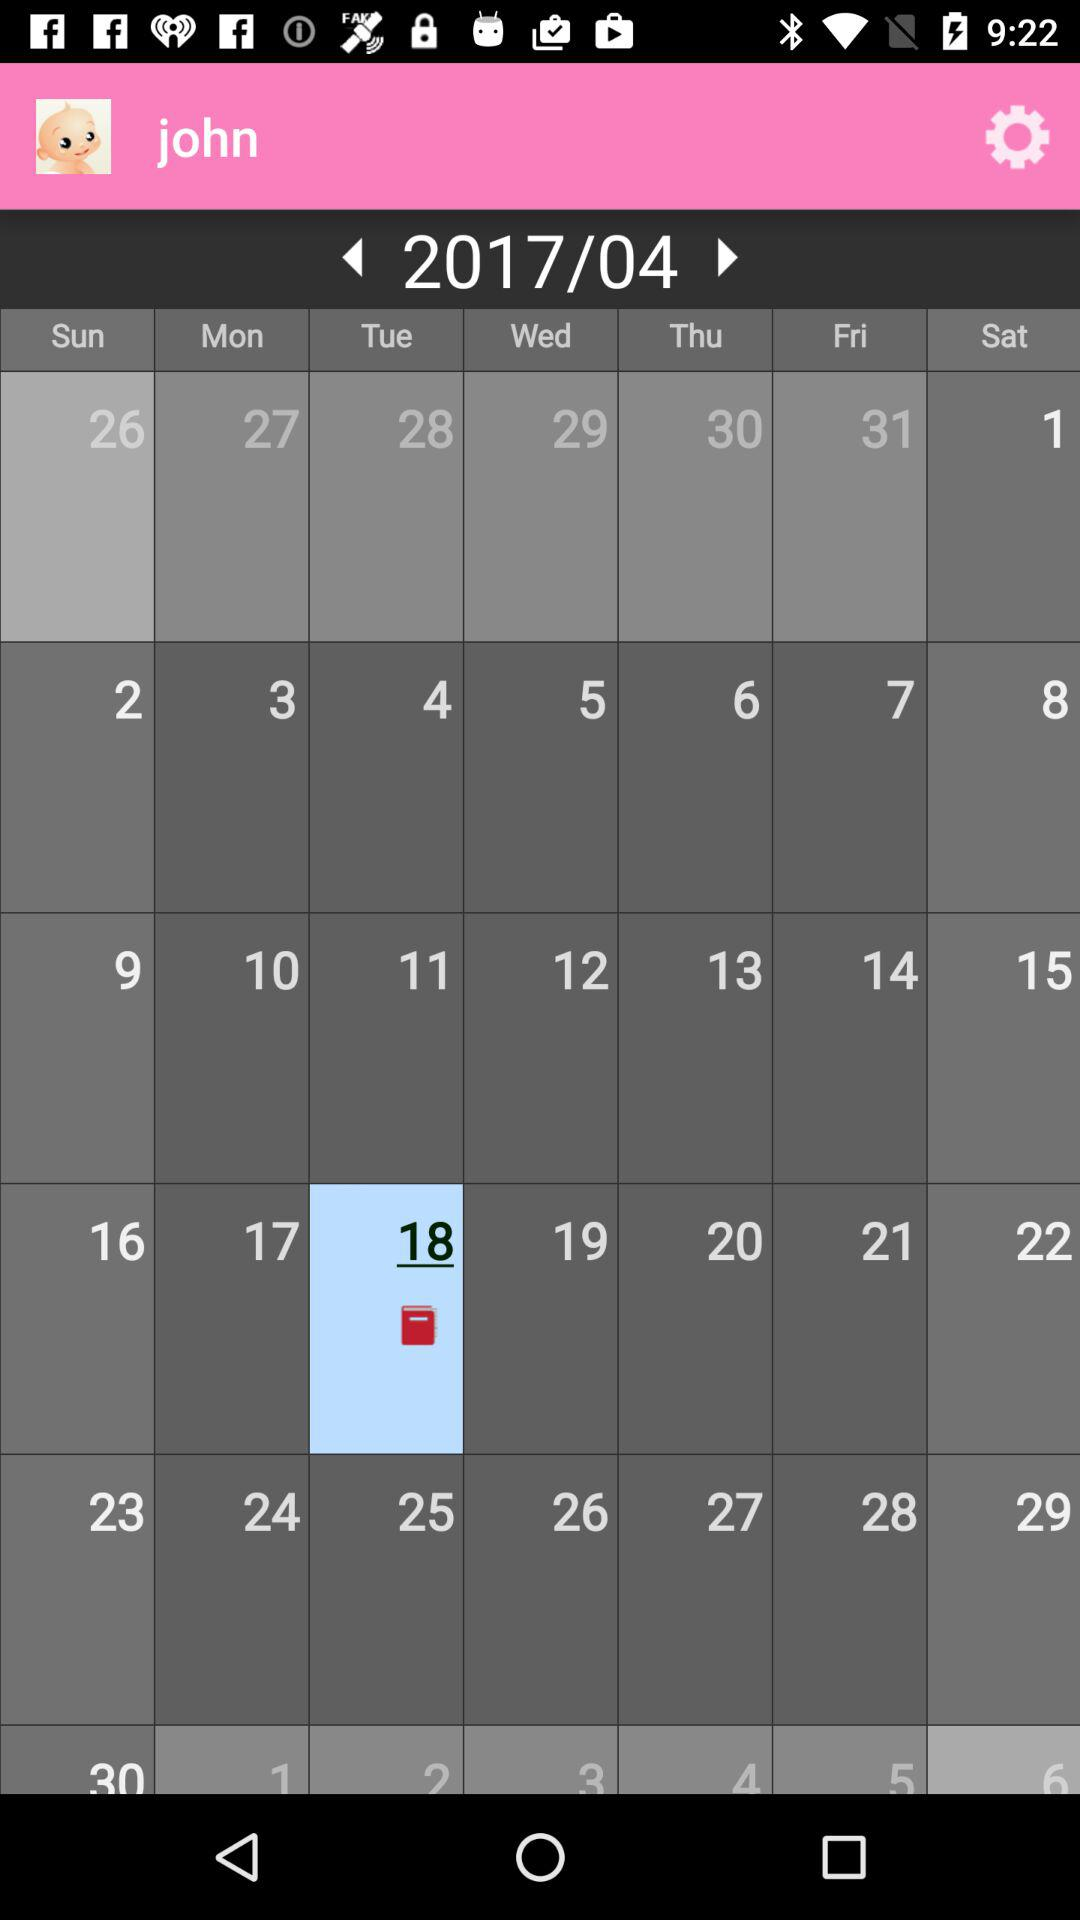What is the selected date? The selected date is Tuesday, April 18, 2017. 